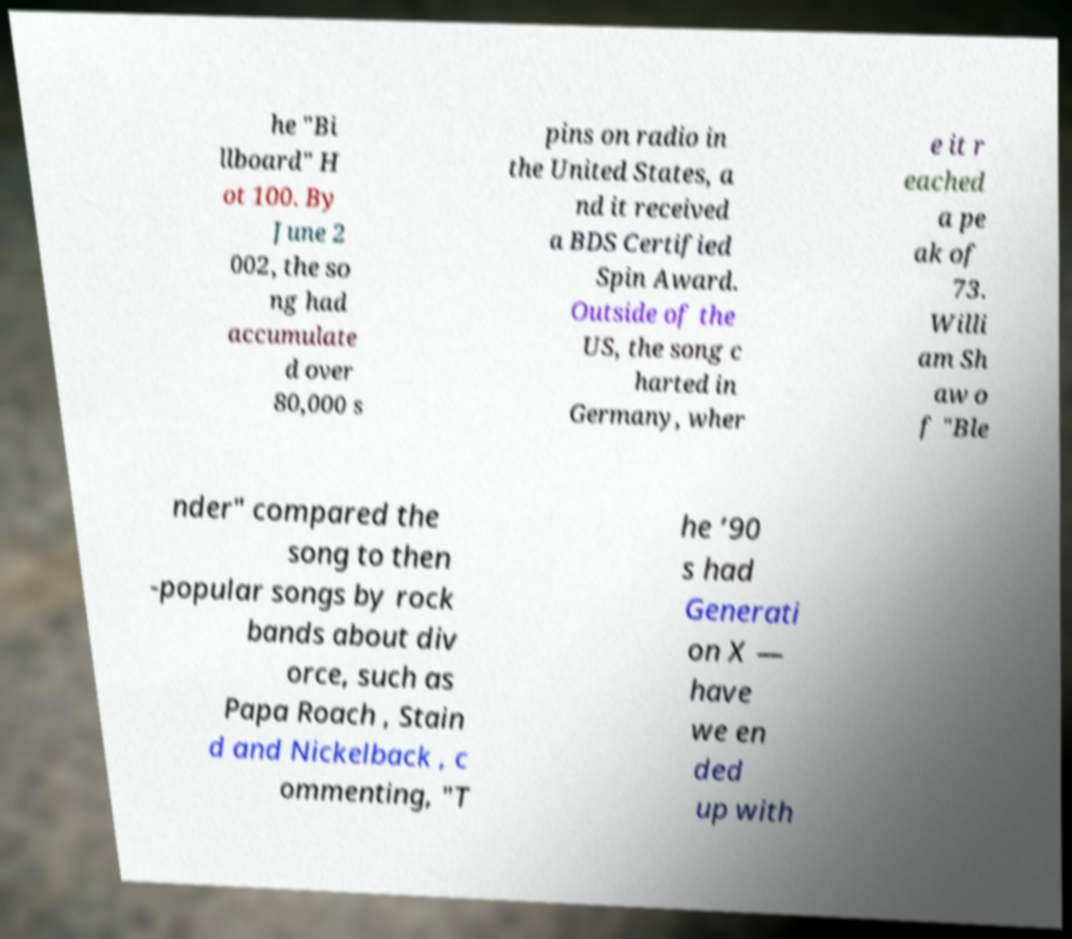Could you assist in decoding the text presented in this image and type it out clearly? he "Bi llboard" H ot 100. By June 2 002, the so ng had accumulate d over 80,000 s pins on radio in the United States, a nd it received a BDS Certified Spin Award. Outside of the US, the song c harted in Germany, wher e it r eached a pe ak of 73. Willi am Sh aw o f "Ble nder" compared the song to then -popular songs by rock bands about div orce, such as Papa Roach , Stain d and Nickelback , c ommenting, "T he ’90 s had Generati on X — have we en ded up with 